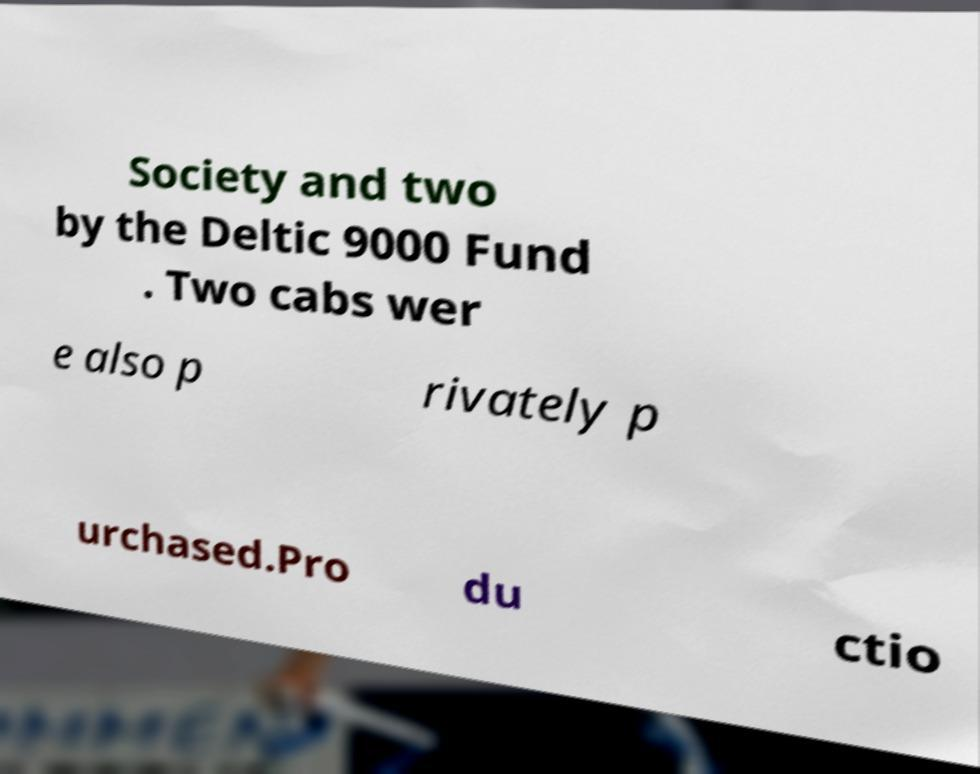For documentation purposes, I need the text within this image transcribed. Could you provide that? Society and two by the Deltic 9000 Fund . Two cabs wer e also p rivately p urchased.Pro du ctio 